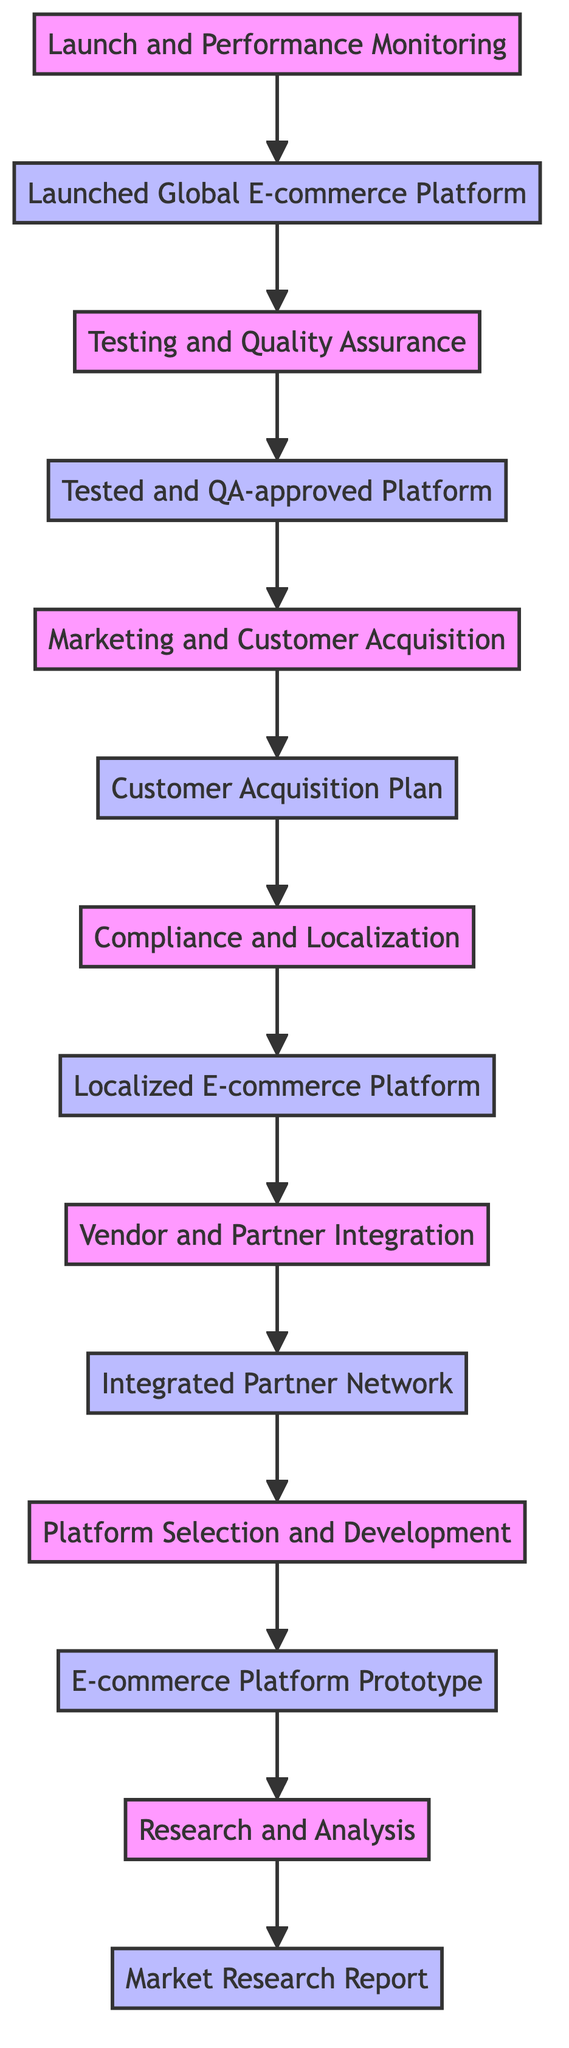What is the first stage in the diagram? The diagram starts with the "Research and Analysis" stage at the bottom. This is the foundational step before any other processes begin.
Answer: Research and Analysis How many outputs are there in total? By counting the outputs associated with each stage, there are seven outputs displayed in the diagram.
Answer: 7 What is the final output of the flow? The last output at the top of the flow chart is "Launched Global E-commerce Platform." It reflects the completion of all prior stages.
Answer: Launched Global E-commerce Platform Which stage follows "Testing and Quality Assurance"? Following the "Testing and Quality Assurance" stage, the next stage in the flow is "Marketing and Customer Acquisition." This indicates that marketing efforts begin after testing.
Answer: Marketing and Customer Acquisition Which stages lead to the "Compliance and Localization" stage? The "Compliance and Localization" stage is preceded by the "Customer Acquisition Plan," indicating that understanding and acquiring customers sets the stage for compliance efforts.
Answer: Customer Acquisition Plan What is the relationship between "Vendor and Partner Integration" and "Platform Selection and Development"? "Vendor and Partner Integration" follows "Compliance and Localization," while "Platform Selection and Development" is connected to "Vendor and Partner Integration," indicating that selecting a platform allows for further integrations.
Answer: Integration What is the output of the "Platform Selection and Development" stage? The output for this stage is "E-commerce Platform Prototype," signifying the tangible result of selecting and developing the platform architecture.
Answer: E-commerce Platform Prototype What is the second stage in the flow? The second stage from the bottom is "Platform Selection and Development," which focuses on technical requirements after market research.
Answer: Platform Selection and Development What precedes "Launch and Performance Monitoring"? Before reaching "Launch and Performance Monitoring," the stage that comes before it is "Testing and Quality Assurance," indicating that thorough testing is essential before launching.
Answer: Testing and Quality Assurance 